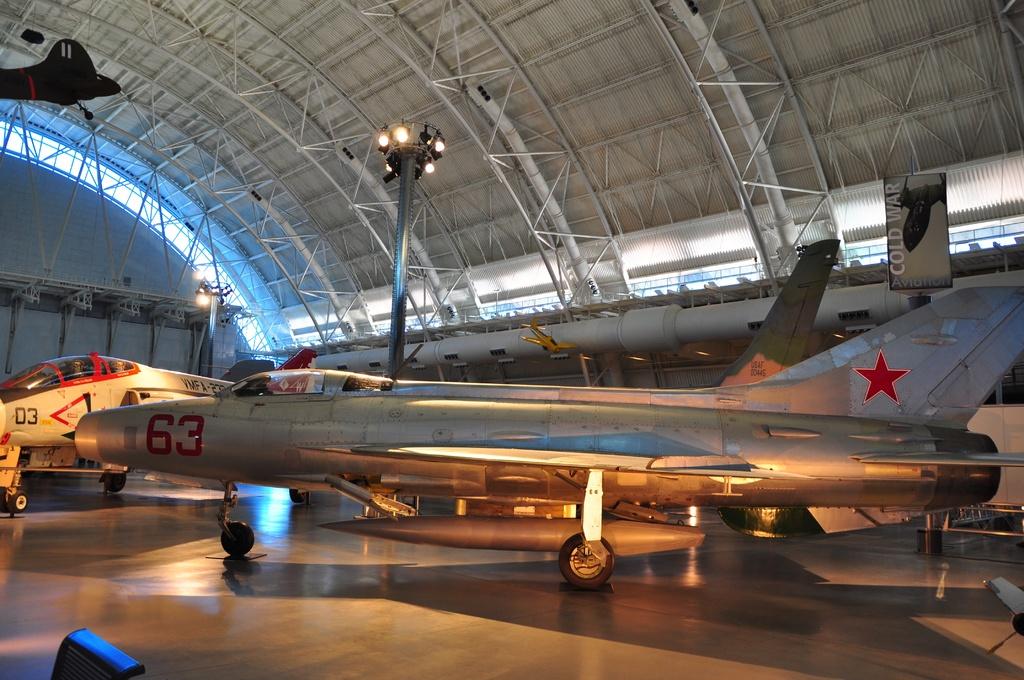What number is on the silver plane?
Offer a very short reply. 63. 